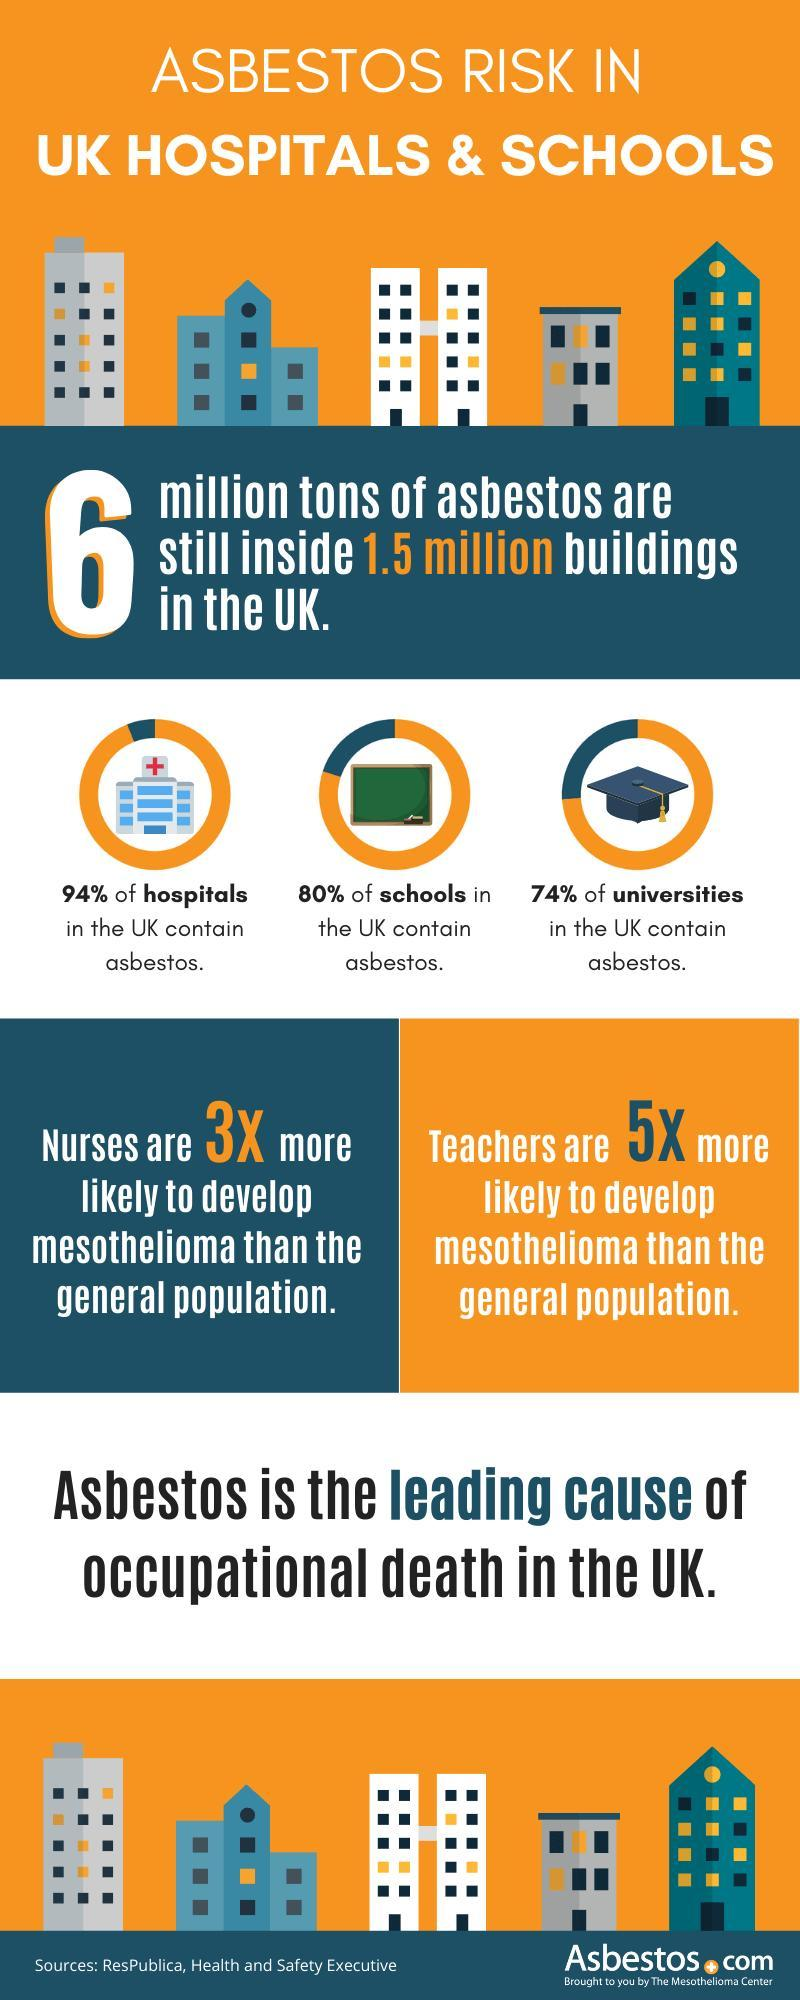What percentage of school buildings in the UK do not contain asbestos?
Answer the question with a short phrase. 20% What percentage of university buildings in the UK do not contain asbestos? 26% What percentage of hospital buildings in the UK do not contain asbestos? 6% 